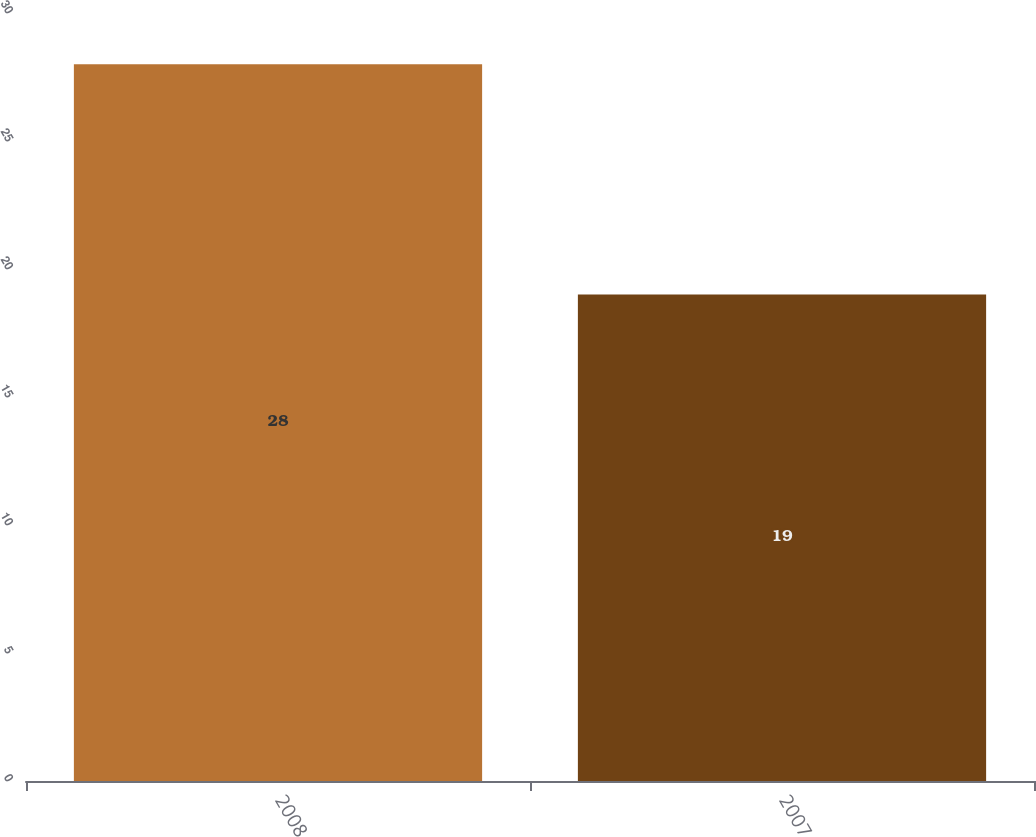Convert chart to OTSL. <chart><loc_0><loc_0><loc_500><loc_500><bar_chart><fcel>2008<fcel>2007<nl><fcel>28<fcel>19<nl></chart> 